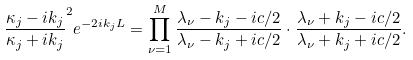<formula> <loc_0><loc_0><loc_500><loc_500>\frac { \kappa _ { j } - i k _ { j } } { \kappa _ { j } + i k _ { j } } ^ { 2 } e ^ { - 2 i k _ { j } L } = \prod _ { \nu = 1 } ^ { M } \frac { \lambda _ { \nu } - k _ { j } - i c / 2 } { \lambda _ { \nu } - k _ { j } + i c / 2 } \cdot \frac { \lambda _ { \nu } + k _ { j } - i c / 2 } { \lambda _ { \nu } + k _ { j } + i c / 2 } .</formula> 